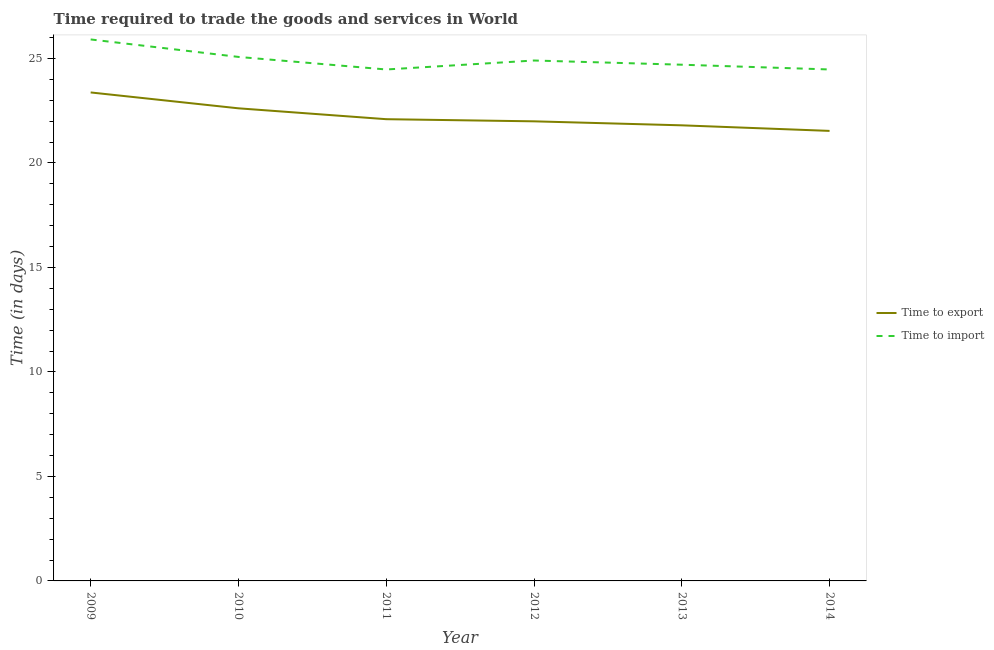How many different coloured lines are there?
Your answer should be compact. 2. Is the number of lines equal to the number of legend labels?
Offer a terse response. Yes. What is the time to import in 2014?
Your answer should be very brief. 24.47. Across all years, what is the maximum time to export?
Offer a very short reply. 23.37. Across all years, what is the minimum time to export?
Offer a very short reply. 21.53. What is the total time to import in the graph?
Keep it short and to the point. 149.52. What is the difference between the time to import in 2009 and that in 2011?
Offer a very short reply. 1.44. What is the difference between the time to export in 2012 and the time to import in 2011?
Make the answer very short. -2.48. What is the average time to export per year?
Ensure brevity in your answer.  22.23. In the year 2012, what is the difference between the time to import and time to export?
Make the answer very short. 2.91. In how many years, is the time to export greater than 6 days?
Ensure brevity in your answer.  6. What is the ratio of the time to import in 2010 to that in 2013?
Ensure brevity in your answer.  1.02. Is the difference between the time to import in 2011 and 2012 greater than the difference between the time to export in 2011 and 2012?
Provide a succinct answer. No. What is the difference between the highest and the second highest time to export?
Provide a short and direct response. 0.76. What is the difference between the highest and the lowest time to import?
Make the answer very short. 1.44. In how many years, is the time to export greater than the average time to export taken over all years?
Give a very brief answer. 2. Does the time to import monotonically increase over the years?
Offer a very short reply. No. Is the time to export strictly greater than the time to import over the years?
Offer a very short reply. No. Is the time to export strictly less than the time to import over the years?
Ensure brevity in your answer.  Yes. How many lines are there?
Offer a very short reply. 2. How many years are there in the graph?
Give a very brief answer. 6. Are the values on the major ticks of Y-axis written in scientific E-notation?
Your answer should be compact. No. Does the graph contain grids?
Offer a very short reply. No. How many legend labels are there?
Keep it short and to the point. 2. How are the legend labels stacked?
Your answer should be very brief. Vertical. What is the title of the graph?
Keep it short and to the point. Time required to trade the goods and services in World. Does "Arms imports" appear as one of the legend labels in the graph?
Make the answer very short. No. What is the label or title of the Y-axis?
Your response must be concise. Time (in days). What is the Time (in days) in Time to export in 2009?
Offer a very short reply. 23.37. What is the Time (in days) in Time to import in 2009?
Your response must be concise. 25.91. What is the Time (in days) of Time to export in 2010?
Your answer should be compact. 22.61. What is the Time (in days) in Time to import in 2010?
Give a very brief answer. 25.07. What is the Time (in days) of Time to export in 2011?
Your response must be concise. 22.09. What is the Time (in days) of Time to import in 2011?
Your answer should be very brief. 24.47. What is the Time (in days) in Time to export in 2012?
Provide a short and direct response. 21.99. What is the Time (in days) of Time to import in 2012?
Your answer should be very brief. 24.9. What is the Time (in days) of Time to export in 2013?
Keep it short and to the point. 21.8. What is the Time (in days) of Time to import in 2013?
Ensure brevity in your answer.  24.7. What is the Time (in days) of Time to export in 2014?
Offer a terse response. 21.53. What is the Time (in days) in Time to import in 2014?
Provide a succinct answer. 24.47. Across all years, what is the maximum Time (in days) in Time to export?
Provide a short and direct response. 23.37. Across all years, what is the maximum Time (in days) in Time to import?
Keep it short and to the point. 25.91. Across all years, what is the minimum Time (in days) in Time to export?
Offer a very short reply. 21.53. Across all years, what is the minimum Time (in days) in Time to import?
Offer a very short reply. 24.47. What is the total Time (in days) of Time to export in the graph?
Your response must be concise. 133.39. What is the total Time (in days) of Time to import in the graph?
Keep it short and to the point. 149.52. What is the difference between the Time (in days) in Time to export in 2009 and that in 2010?
Your answer should be very brief. 0.76. What is the difference between the Time (in days) in Time to import in 2009 and that in 2010?
Your response must be concise. 0.84. What is the difference between the Time (in days) in Time to export in 2009 and that in 2011?
Keep it short and to the point. 1.28. What is the difference between the Time (in days) in Time to import in 2009 and that in 2011?
Offer a very short reply. 1.44. What is the difference between the Time (in days) of Time to export in 2009 and that in 2012?
Your answer should be very brief. 1.38. What is the difference between the Time (in days) of Time to import in 2009 and that in 2012?
Provide a short and direct response. 1.01. What is the difference between the Time (in days) in Time to export in 2009 and that in 2013?
Keep it short and to the point. 1.57. What is the difference between the Time (in days) in Time to import in 2009 and that in 2013?
Your answer should be very brief. 1.21. What is the difference between the Time (in days) in Time to export in 2009 and that in 2014?
Provide a short and direct response. 1.84. What is the difference between the Time (in days) of Time to import in 2009 and that in 2014?
Offer a very short reply. 1.44. What is the difference between the Time (in days) in Time to export in 2010 and that in 2011?
Your response must be concise. 0.52. What is the difference between the Time (in days) of Time to import in 2010 and that in 2011?
Your response must be concise. 0.6. What is the difference between the Time (in days) in Time to export in 2010 and that in 2012?
Offer a very short reply. 0.62. What is the difference between the Time (in days) of Time to import in 2010 and that in 2012?
Offer a very short reply. 0.17. What is the difference between the Time (in days) in Time to export in 2010 and that in 2013?
Provide a succinct answer. 0.81. What is the difference between the Time (in days) in Time to import in 2010 and that in 2013?
Offer a terse response. 0.37. What is the difference between the Time (in days) in Time to export in 2010 and that in 2014?
Your answer should be compact. 1.08. What is the difference between the Time (in days) in Time to import in 2010 and that in 2014?
Your answer should be compact. 0.6. What is the difference between the Time (in days) of Time to export in 2011 and that in 2012?
Provide a succinct answer. 0.1. What is the difference between the Time (in days) in Time to import in 2011 and that in 2012?
Your answer should be compact. -0.43. What is the difference between the Time (in days) of Time to export in 2011 and that in 2013?
Your response must be concise. 0.29. What is the difference between the Time (in days) of Time to import in 2011 and that in 2013?
Make the answer very short. -0.23. What is the difference between the Time (in days) of Time to export in 2011 and that in 2014?
Make the answer very short. 0.56. What is the difference between the Time (in days) in Time to import in 2011 and that in 2014?
Offer a terse response. -0. What is the difference between the Time (in days) in Time to export in 2012 and that in 2013?
Your answer should be compact. 0.19. What is the difference between the Time (in days) of Time to import in 2012 and that in 2013?
Provide a succinct answer. 0.2. What is the difference between the Time (in days) of Time to export in 2012 and that in 2014?
Provide a short and direct response. 0.46. What is the difference between the Time (in days) in Time to import in 2012 and that in 2014?
Keep it short and to the point. 0.43. What is the difference between the Time (in days) in Time to export in 2013 and that in 2014?
Provide a short and direct response. 0.27. What is the difference between the Time (in days) of Time to import in 2013 and that in 2014?
Your response must be concise. 0.23. What is the difference between the Time (in days) of Time to export in 2009 and the Time (in days) of Time to import in 2010?
Ensure brevity in your answer.  -1.7. What is the difference between the Time (in days) of Time to export in 2009 and the Time (in days) of Time to import in 2011?
Provide a short and direct response. -1.1. What is the difference between the Time (in days) of Time to export in 2009 and the Time (in days) of Time to import in 2012?
Offer a very short reply. -1.53. What is the difference between the Time (in days) in Time to export in 2009 and the Time (in days) in Time to import in 2013?
Make the answer very short. -1.33. What is the difference between the Time (in days) in Time to export in 2009 and the Time (in days) in Time to import in 2014?
Your answer should be compact. -1.1. What is the difference between the Time (in days) of Time to export in 2010 and the Time (in days) of Time to import in 2011?
Your response must be concise. -1.86. What is the difference between the Time (in days) in Time to export in 2010 and the Time (in days) in Time to import in 2012?
Ensure brevity in your answer.  -2.29. What is the difference between the Time (in days) in Time to export in 2010 and the Time (in days) in Time to import in 2013?
Your response must be concise. -2.09. What is the difference between the Time (in days) in Time to export in 2010 and the Time (in days) in Time to import in 2014?
Your answer should be compact. -1.86. What is the difference between the Time (in days) of Time to export in 2011 and the Time (in days) of Time to import in 2012?
Your answer should be compact. -2.81. What is the difference between the Time (in days) of Time to export in 2011 and the Time (in days) of Time to import in 2013?
Provide a succinct answer. -2.61. What is the difference between the Time (in days) of Time to export in 2011 and the Time (in days) of Time to import in 2014?
Ensure brevity in your answer.  -2.38. What is the difference between the Time (in days) in Time to export in 2012 and the Time (in days) in Time to import in 2013?
Ensure brevity in your answer.  -2.71. What is the difference between the Time (in days) in Time to export in 2012 and the Time (in days) in Time to import in 2014?
Keep it short and to the point. -2.48. What is the difference between the Time (in days) in Time to export in 2013 and the Time (in days) in Time to import in 2014?
Ensure brevity in your answer.  -2.67. What is the average Time (in days) of Time to export per year?
Make the answer very short. 22.23. What is the average Time (in days) in Time to import per year?
Make the answer very short. 24.92. In the year 2009, what is the difference between the Time (in days) in Time to export and Time (in days) in Time to import?
Your answer should be compact. -2.54. In the year 2010, what is the difference between the Time (in days) of Time to export and Time (in days) of Time to import?
Provide a short and direct response. -2.46. In the year 2011, what is the difference between the Time (in days) in Time to export and Time (in days) in Time to import?
Offer a terse response. -2.38. In the year 2012, what is the difference between the Time (in days) of Time to export and Time (in days) of Time to import?
Your answer should be very brief. -2.91. In the year 2013, what is the difference between the Time (in days) of Time to export and Time (in days) of Time to import?
Make the answer very short. -2.9. In the year 2014, what is the difference between the Time (in days) of Time to export and Time (in days) of Time to import?
Your response must be concise. -2.94. What is the ratio of the Time (in days) of Time to export in 2009 to that in 2010?
Keep it short and to the point. 1.03. What is the ratio of the Time (in days) in Time to export in 2009 to that in 2011?
Offer a very short reply. 1.06. What is the ratio of the Time (in days) in Time to import in 2009 to that in 2011?
Provide a short and direct response. 1.06. What is the ratio of the Time (in days) of Time to export in 2009 to that in 2012?
Offer a very short reply. 1.06. What is the ratio of the Time (in days) in Time to import in 2009 to that in 2012?
Your response must be concise. 1.04. What is the ratio of the Time (in days) of Time to export in 2009 to that in 2013?
Your answer should be very brief. 1.07. What is the ratio of the Time (in days) of Time to import in 2009 to that in 2013?
Make the answer very short. 1.05. What is the ratio of the Time (in days) in Time to export in 2009 to that in 2014?
Provide a short and direct response. 1.09. What is the ratio of the Time (in days) of Time to import in 2009 to that in 2014?
Ensure brevity in your answer.  1.06. What is the ratio of the Time (in days) in Time to export in 2010 to that in 2011?
Your response must be concise. 1.02. What is the ratio of the Time (in days) in Time to import in 2010 to that in 2011?
Give a very brief answer. 1.02. What is the ratio of the Time (in days) of Time to export in 2010 to that in 2012?
Make the answer very short. 1.03. What is the ratio of the Time (in days) of Time to import in 2010 to that in 2012?
Ensure brevity in your answer.  1.01. What is the ratio of the Time (in days) in Time to export in 2010 to that in 2013?
Offer a very short reply. 1.04. What is the ratio of the Time (in days) in Time to import in 2010 to that in 2013?
Offer a very short reply. 1.02. What is the ratio of the Time (in days) in Time to export in 2010 to that in 2014?
Offer a very short reply. 1.05. What is the ratio of the Time (in days) in Time to import in 2010 to that in 2014?
Keep it short and to the point. 1.02. What is the ratio of the Time (in days) in Time to import in 2011 to that in 2012?
Offer a terse response. 0.98. What is the ratio of the Time (in days) in Time to export in 2011 to that in 2013?
Provide a short and direct response. 1.01. What is the ratio of the Time (in days) in Time to import in 2011 to that in 2014?
Provide a short and direct response. 1. What is the ratio of the Time (in days) of Time to export in 2012 to that in 2013?
Ensure brevity in your answer.  1.01. What is the ratio of the Time (in days) in Time to import in 2012 to that in 2013?
Make the answer very short. 1.01. What is the ratio of the Time (in days) of Time to export in 2012 to that in 2014?
Your answer should be compact. 1.02. What is the ratio of the Time (in days) in Time to import in 2012 to that in 2014?
Provide a short and direct response. 1.02. What is the ratio of the Time (in days) of Time to export in 2013 to that in 2014?
Offer a very short reply. 1.01. What is the ratio of the Time (in days) of Time to import in 2013 to that in 2014?
Provide a short and direct response. 1.01. What is the difference between the highest and the second highest Time (in days) in Time to export?
Your response must be concise. 0.76. What is the difference between the highest and the second highest Time (in days) in Time to import?
Offer a terse response. 0.84. What is the difference between the highest and the lowest Time (in days) of Time to export?
Your response must be concise. 1.84. What is the difference between the highest and the lowest Time (in days) of Time to import?
Your answer should be compact. 1.44. 